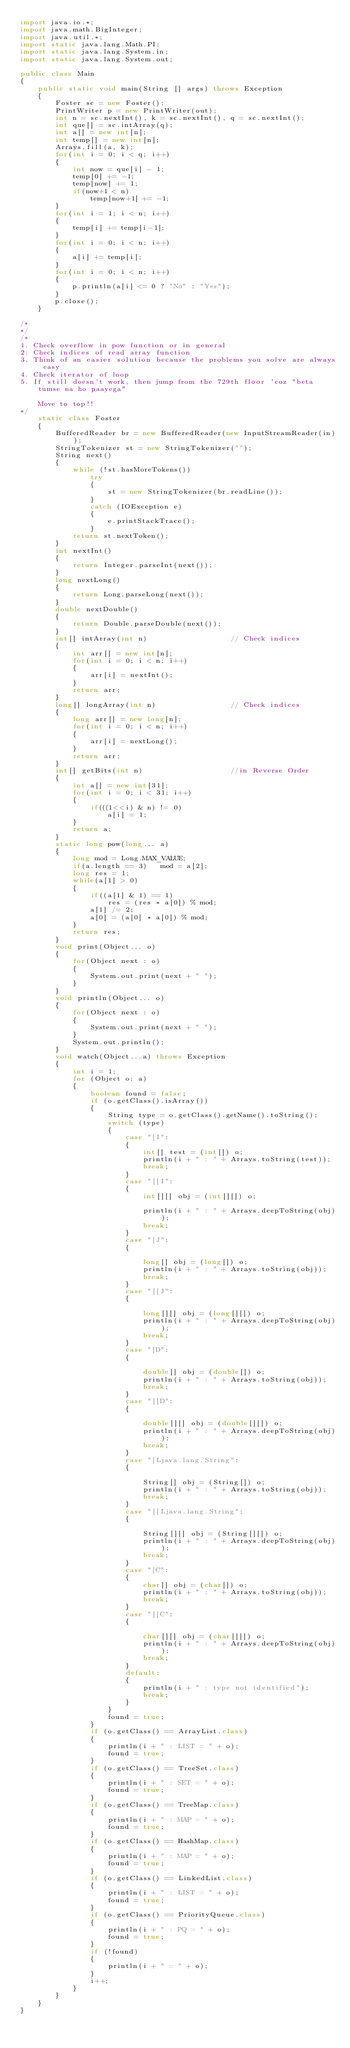<code> <loc_0><loc_0><loc_500><loc_500><_Java_>import java.io.*;
import java.math.BigInteger;
import java.util.*;
import static java.lang.Math.PI;
import static java.lang.System.in;
import static java.lang.System.out;

public class Main
{    
    public static void main(String [] args) throws Exception
    {
        Foster sc = new Foster();
        PrintWriter p = new PrintWriter(out);
        int n = sc.nextInt(), k = sc.nextInt(), q = sc.nextInt();
        int que[] = sc.intArray(q);
        int a[] = new int[n];
        int temp[] = new int[n];
        Arrays.fill(a, k);
        for(int i = 0; i < q; i++)
        {
            int now = que[i] - 1;
            temp[0] += -1;
            temp[now] += 1;
            if(now+1 < n)
                temp[now+1] += -1;
        }
        for(int i = 1; i < n; i++)
        {
            temp[i] += temp[i-1];
        }
        for(int i = 0; i < n; i++)
        {
            a[i] += temp[i];
        }
        for(int i = 0; i < n; i++)
        {
            p.println(a[i] <= 0 ? "No" : "Yes");
        }
        p.close();
    }

/*
*/    
/*
1. Check overflow in pow function or in general
2. Check indices of read array function
3. Think of an easier solution because the problems you solve are always easy
4. Check iterator of loop
5. If still doesn't work, then jump from the 729th floor 'coz "beta tumse na ho paayega"

    Move to top!!
*/
    static class Foster 
    {
        BufferedReader br = new BufferedReader(new InputStreamReader(in));
        StringTokenizer st = new StringTokenizer("");
        String next() 
        {
            while (!st.hasMoreTokens())
                try 
                {
                    st = new StringTokenizer(br.readLine());
                } 
                catch (IOException e) 
                {
                    e.printStackTrace();
                }
            return st.nextToken();
        }
        int nextInt() 
        {
            return Integer.parseInt(next());
        }
        long nextLong() 
        {
            return Long.parseLong(next());
        }
        double nextDouble() 
        {
            return Double.parseDouble(next());
        }
        int[] intArray(int n)                   // Check indices
        {
            int arr[] = new int[n];
            for(int i = 0; i < n; i++)
            {
                arr[i] = nextInt();
            }
            return arr;
        }
        long[] longArray(int n)                 // Check indices
        {
            long arr[] = new long[n];
            for(int i = 0; i < n; i++)
            {
                arr[i] = nextLong();
            }
            return arr;
        }
        int[] getBits(int n)                    //in Reverse Order
        {
            int a[] = new int[31];
            for(int i = 0; i < 31; i++)
            {
                if(((1<<i) & n) != 0)
                    a[i] = 1;
            }
            return a;
        }
        static long pow(long... a)
        {
            long mod = Long.MAX_VALUE;
            if(a.length == 3)   mod = a[2];
            long res = 1;
            while(a[1] > 0)
            {
                if((a[1] & 1) == 1)
                    res = (res * a[0]) % mod;
                a[1] /= 2;
                a[0] = (a[0] * a[0]) % mod;
            }
            return res;
        }
        void print(Object... o) 
        {
            for(Object next : o)
            {
                System.out.print(next + " ");
            }
        }
        void println(Object... o) 
        {
            for(Object next : o)
            {
                System.out.print(next + " ");
            }
            System.out.println();
        }
        void watch(Object...a) throws Exception 
        {
            int i = 1;
            for (Object o: a) 
            {
                boolean found = false;
                if (o.getClass().isArray()) 
                {
                    String type = o.getClass().getName().toString();
                    switch (type) 
                    {
                        case "[I":
                        {
                            int[] test = (int[]) o;
                            println(i + " : " + Arrays.toString(test));
                            break;
                        }
                        case "[[I":
                        {
                            int[][] obj = (int[][]) o;

                            println(i + " : " + Arrays.deepToString(obj));
                            break;
                        }
                        case "[J":
                        {

                            long[] obj = (long[]) o;
                            println(i + " : " + Arrays.toString(obj));
                            break;
                        }
                        case "[[J":
                        {

                            long[][] obj = (long[][]) o;
                            println(i + " : " + Arrays.deepToString(obj));
                            break;
                        }
                        case "[D":
                        {

                            double[] obj = (double[]) o;
                            println(i + " : " + Arrays.toString(obj));
                            break;
                        }
                        case "[[D":
                        {

                            double[][] obj = (double[][]) o;
                            println(i + " : " + Arrays.deepToString(obj));
                            break;
                        }
                        case "[Ljava.lang.String":
                        {

                            String[] obj = (String[]) o;
                            println(i + " : " + Arrays.toString(obj));
                            break;
                        }
                        case "[[Ljava.lang.String":
                        {

                            String[][] obj = (String[][]) o;
                            println(i + " : " + Arrays.deepToString(obj));
                            break;
                        }
                        case "[C":
                        {
                            char[] obj = (char[]) o;
                            println(i + " : " + Arrays.toString(obj));
                            break;
                        }
                        case "[[C":
                        {

                            char[][] obj = (char[][]) o;
                            println(i + " : " + Arrays.deepToString(obj));
                            break;
                        }
                        default:
                        {
                            println(i + " : type not identified");
                            break;
                        }
                    }
                    found = true;
                }
                if (o.getClass() == ArrayList.class) 
                {
                    println(i + " : LIST = " + o);
                    found = true;
                }
                if (o.getClass() == TreeSet.class) 
                {
                    println(i + " : SET = " + o);
                    found = true;
                }
                if (o.getClass() == TreeMap.class) 
                {
                    println(i + " : MAP = " + o);
                    found = true;
                }
                if (o.getClass() == HashMap.class) 
                {
                    println(i + " : MAP = " + o);
                    found = true;
                }
                if (o.getClass() == LinkedList.class) 
                {
                    println(i + " : LIST = " + o);
                    found = true;
                }
                if (o.getClass() == PriorityQueue.class) 
                {
                    println(i + " : PQ = " + o);
                    found = true;
                }
                if (!found) 
                {
                    println(i + " = " + o);
                }
                i++;
            }
        }
    }
}</code> 